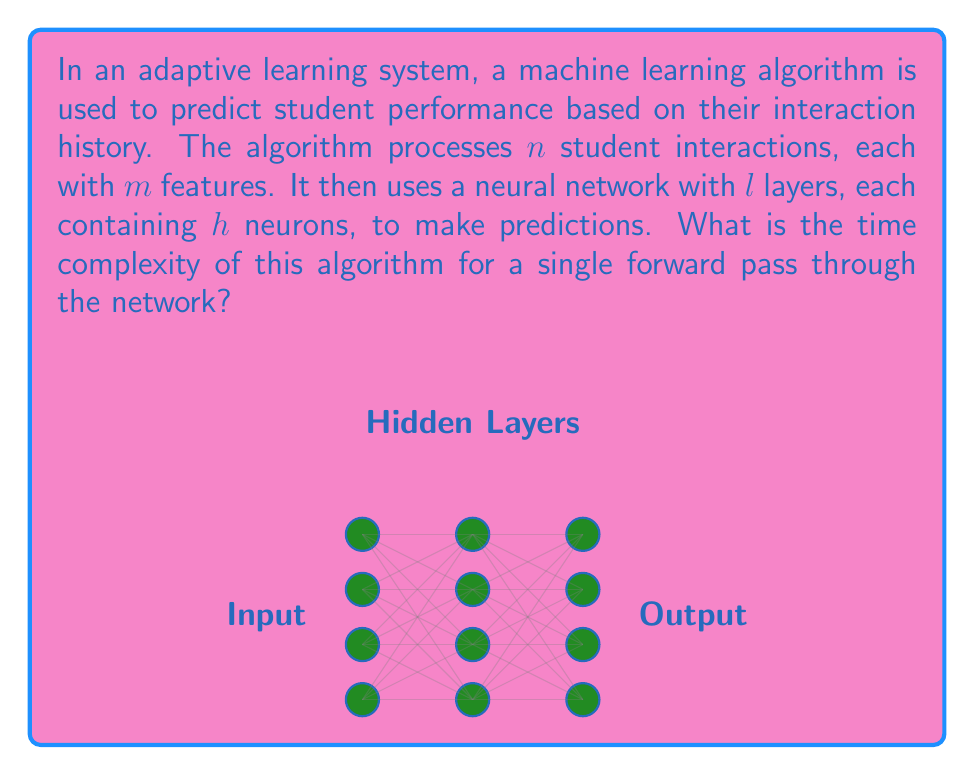Give your solution to this math problem. To determine the time complexity, we need to consider the operations performed in a forward pass through the neural network:

1. Input processing:
   - We have $n$ student interactions, each with $m$ features.
   - Time complexity for input processing: $O(nm)$

2. Neural network computation:
   - The network has $l$ layers, each with $h$ neurons.
   - For each layer:
     a. Each neuron performs a dot product with the previous layer's outputs.
     b. The number of operations for one neuron is proportional to the number of neurons in the previous layer.
   - Time complexity for one layer: $O(h^2)$
   - Total time complexity for $l$ layers: $O(lh^2)$

3. Combining the input processing and network computation:
   - The total time complexity is the sum of the two parts:
     $O(nm + lh^2)$

4. In practice, the number of layers $l$ and neurons per layer $h$ are typically fixed for a given model architecture. Therefore, we can consider $l$ and $h$ as constants.

5. With $l$ and $h$ as constants, the time complexity simplifies to:
   $O(nm + c)$, where $c$ is a constant.

6. In Big O notation, we can drop the constant term, resulting in a final time complexity of:
   $O(nm)$

This complexity indicates that the algorithm's running time grows linearly with both the number of student interactions and the number of features per interaction.
Answer: $O(nm)$ 